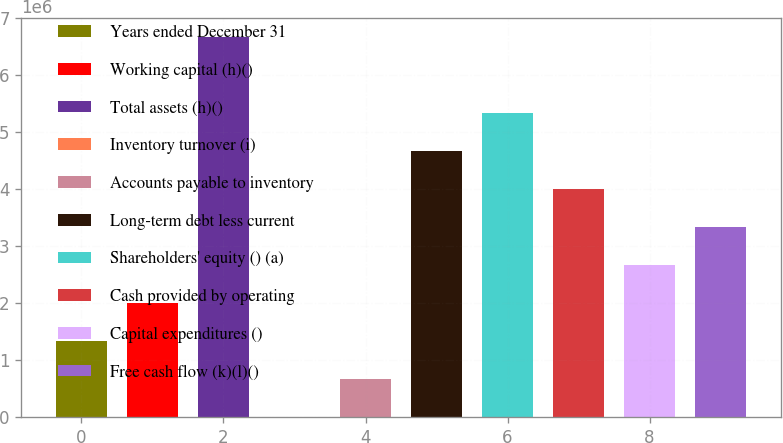<chart> <loc_0><loc_0><loc_500><loc_500><bar_chart><fcel>Years ended December 31<fcel>Working capital (h)()<fcel>Total assets (h)()<fcel>Inventory turnover (i)<fcel>Accounts payable to inventory<fcel>Long-term debt less current<fcel>Shareholders' equity () (a)<fcel>Cash provided by operating<fcel>Capital expenditures ()<fcel>Free cash flow (k)(l)()<nl><fcel>1.33534e+06<fcel>2.00301e+06<fcel>6.67668e+06<fcel>1.5<fcel>667670<fcel>4.67368e+06<fcel>5.34135e+06<fcel>4.00601e+06<fcel>2.67067e+06<fcel>3.33834e+06<nl></chart> 